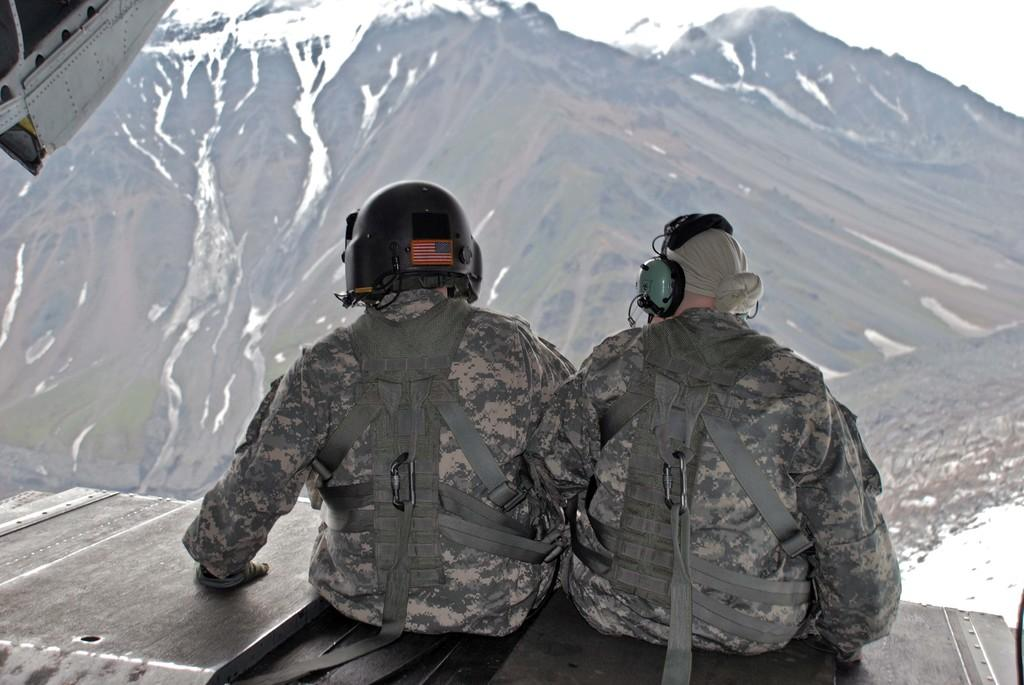What are the people sitting on in the image? The people are sitting on an iron surface that resembles an airplane. What type of landscape can be seen in the image? Mountains are visible in the image. What is the weather like in the image? There is snow present in the image, indicating a cold or wintry environment. What type of chicken is being cooked by the stranger in the image? There is no chicken or stranger present in the image. 